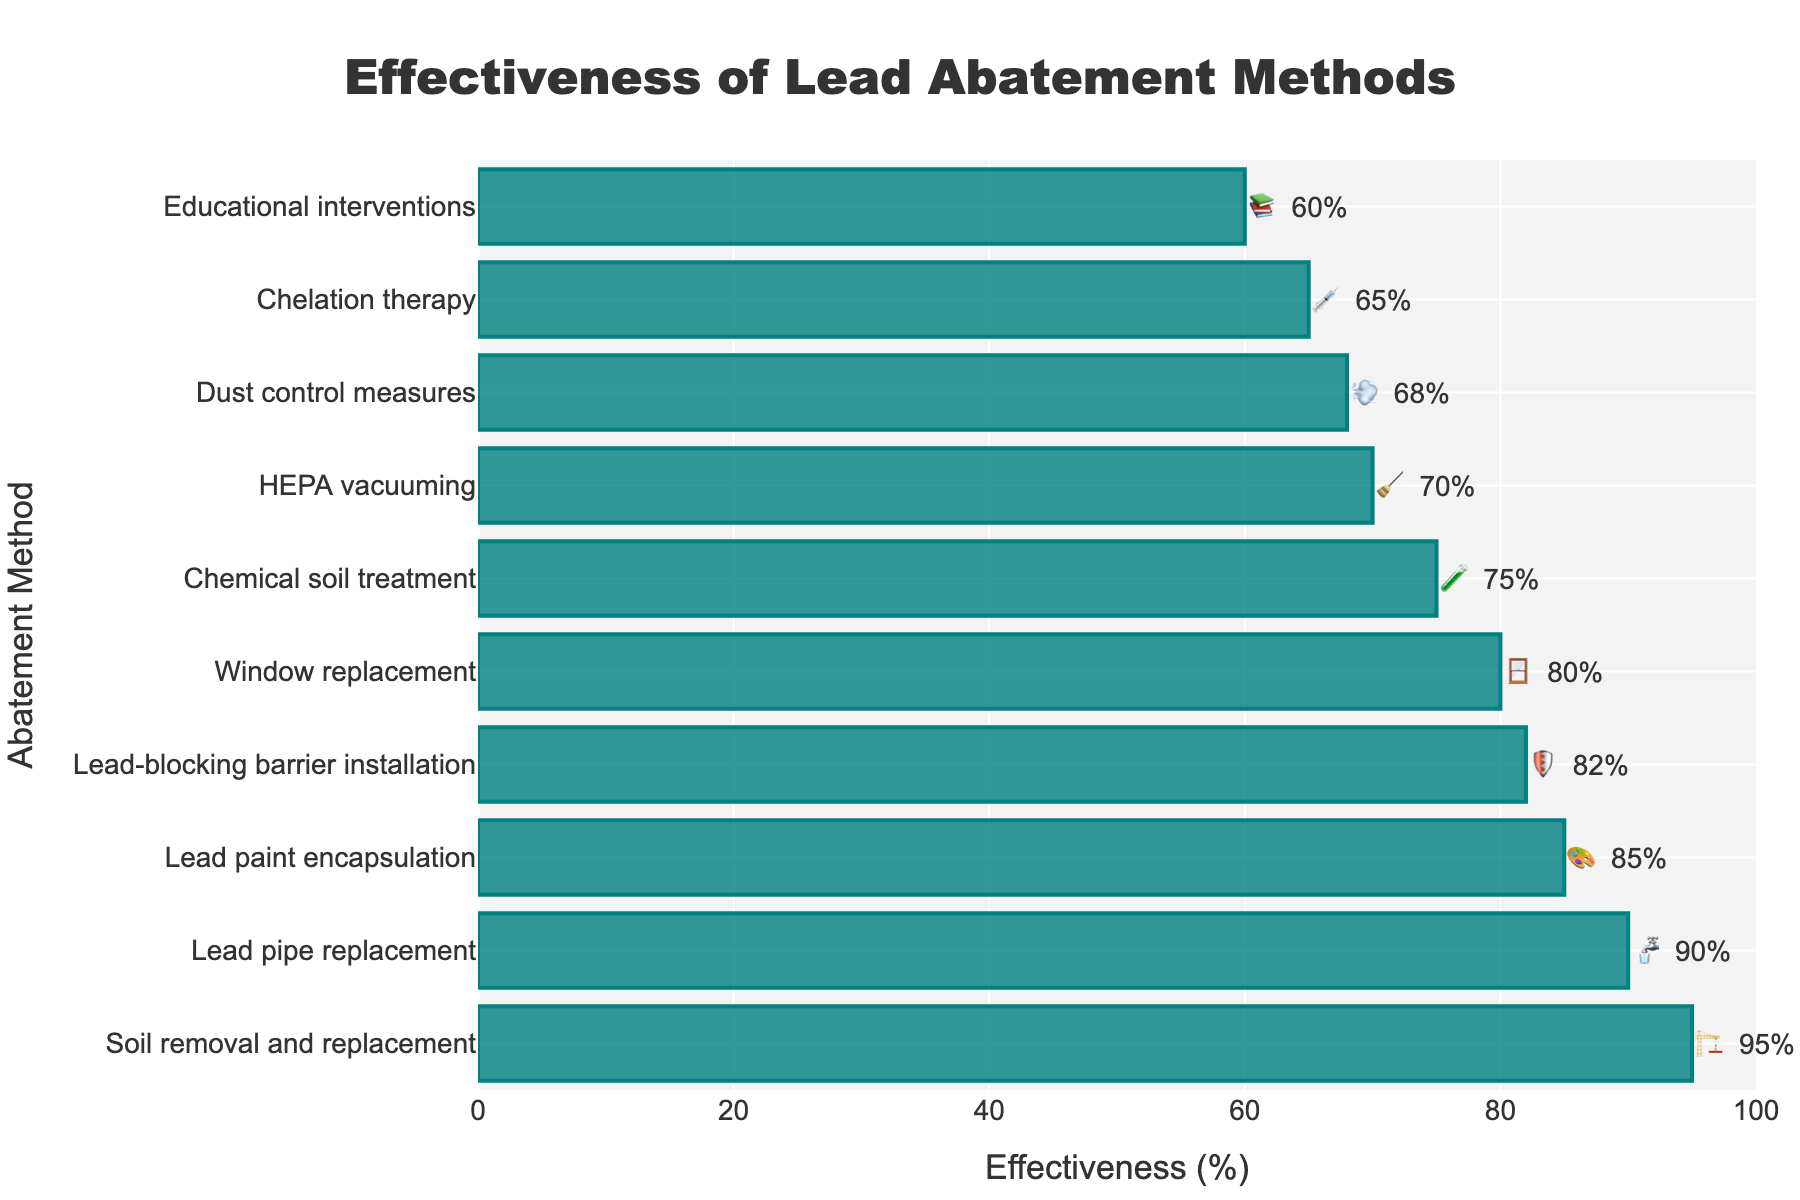What's the title of the figure? The title is located at the top of the figure in a bigger font. It's centrally aligned, easily readable, and states the overall purpose of the plot.
Answer: Effectiveness of Lead Abatement Methods What is the effectiveness (%) of the most effective lead abatement method? Look at the bar that extends furthest to the right, which represents the highest effectiveness percentage. This bar corresponds to the soil removal and replacement method.
Answer: 95% Which lead abatement method has an emoji with a paintbrush? The emoji with a paintbrush is "🎨," which corresponds to "Lead paint encapsulation."
Answer: Lead paint encapsulation How many methods have an effectiveness (%) above 80%? Count the number of bars that extend beyond the 80% mark on the x-axis. These bars correspond to the methods: Soil removal and replacement, Lead pipe replacement, Lead paint encapsulation, Window replacement, and Lead-blocking barrier installation.
Answer: 5 methods What is the average effectiveness (%) of the top three methods? First, identify the top three methods: Soil removal and replacement (95%), Lead pipe replacement (90%), and Lead paint encapsulation (85%). Then, calculate the average: (95 + 90 + 85) / 3 = 270 / 3 = 90.
Answer: 90% Which method has an effectiveness (%) closest to the average effectiveness of all methods? Find the average effectiveness by summing all effectiveness percentages and dividing by the number of methods: (95 + 85 + 80 + 70 + 65 + 90 + 75 + 82 + 68 + 60) / 10 = 770 / 10 = 77%. The method closest to 77% is Chemical soil treatment at 75%.
Answer: Chemical soil treatment What is the effectiveness difference between HEPA vacuuming and Chelation therapy? Identify the effectiveness percentages for HEPA vacuuming (70%) and Chelation therapy (65%). Subtract the smaller number from the larger number: 70% - 65% = 5%.
Answer: 5% Compare the effectiveness of Window replacement and Lead-blocking barrier installation. Which is more effective? Look at the bars corresponding to these methods. Window replacement is at 80%, while Lead-blocking barrier installation is at 82%. Therefore, Lead-blocking barrier installation is more effective.
Answer: Lead-blocking barrier installation What proportion of the methods are less than 70% effective? Identify the total number of methods (10) and count how many have effectiveness percentages below 70%: Chelation therapy (65%), Dust control measures (68%), and Educational interventions (60%). There are 3 methods. Calculate the proportion: 3 / 10 = 0.3 or 30%.
Answer: 30% Which method has the least effectiveness and what is its designation (emoji)? Observe the bar that extends the least to the right. The method is "Educational interventions," and its emoji is "📚."
Answer: Educational interventions 📚 